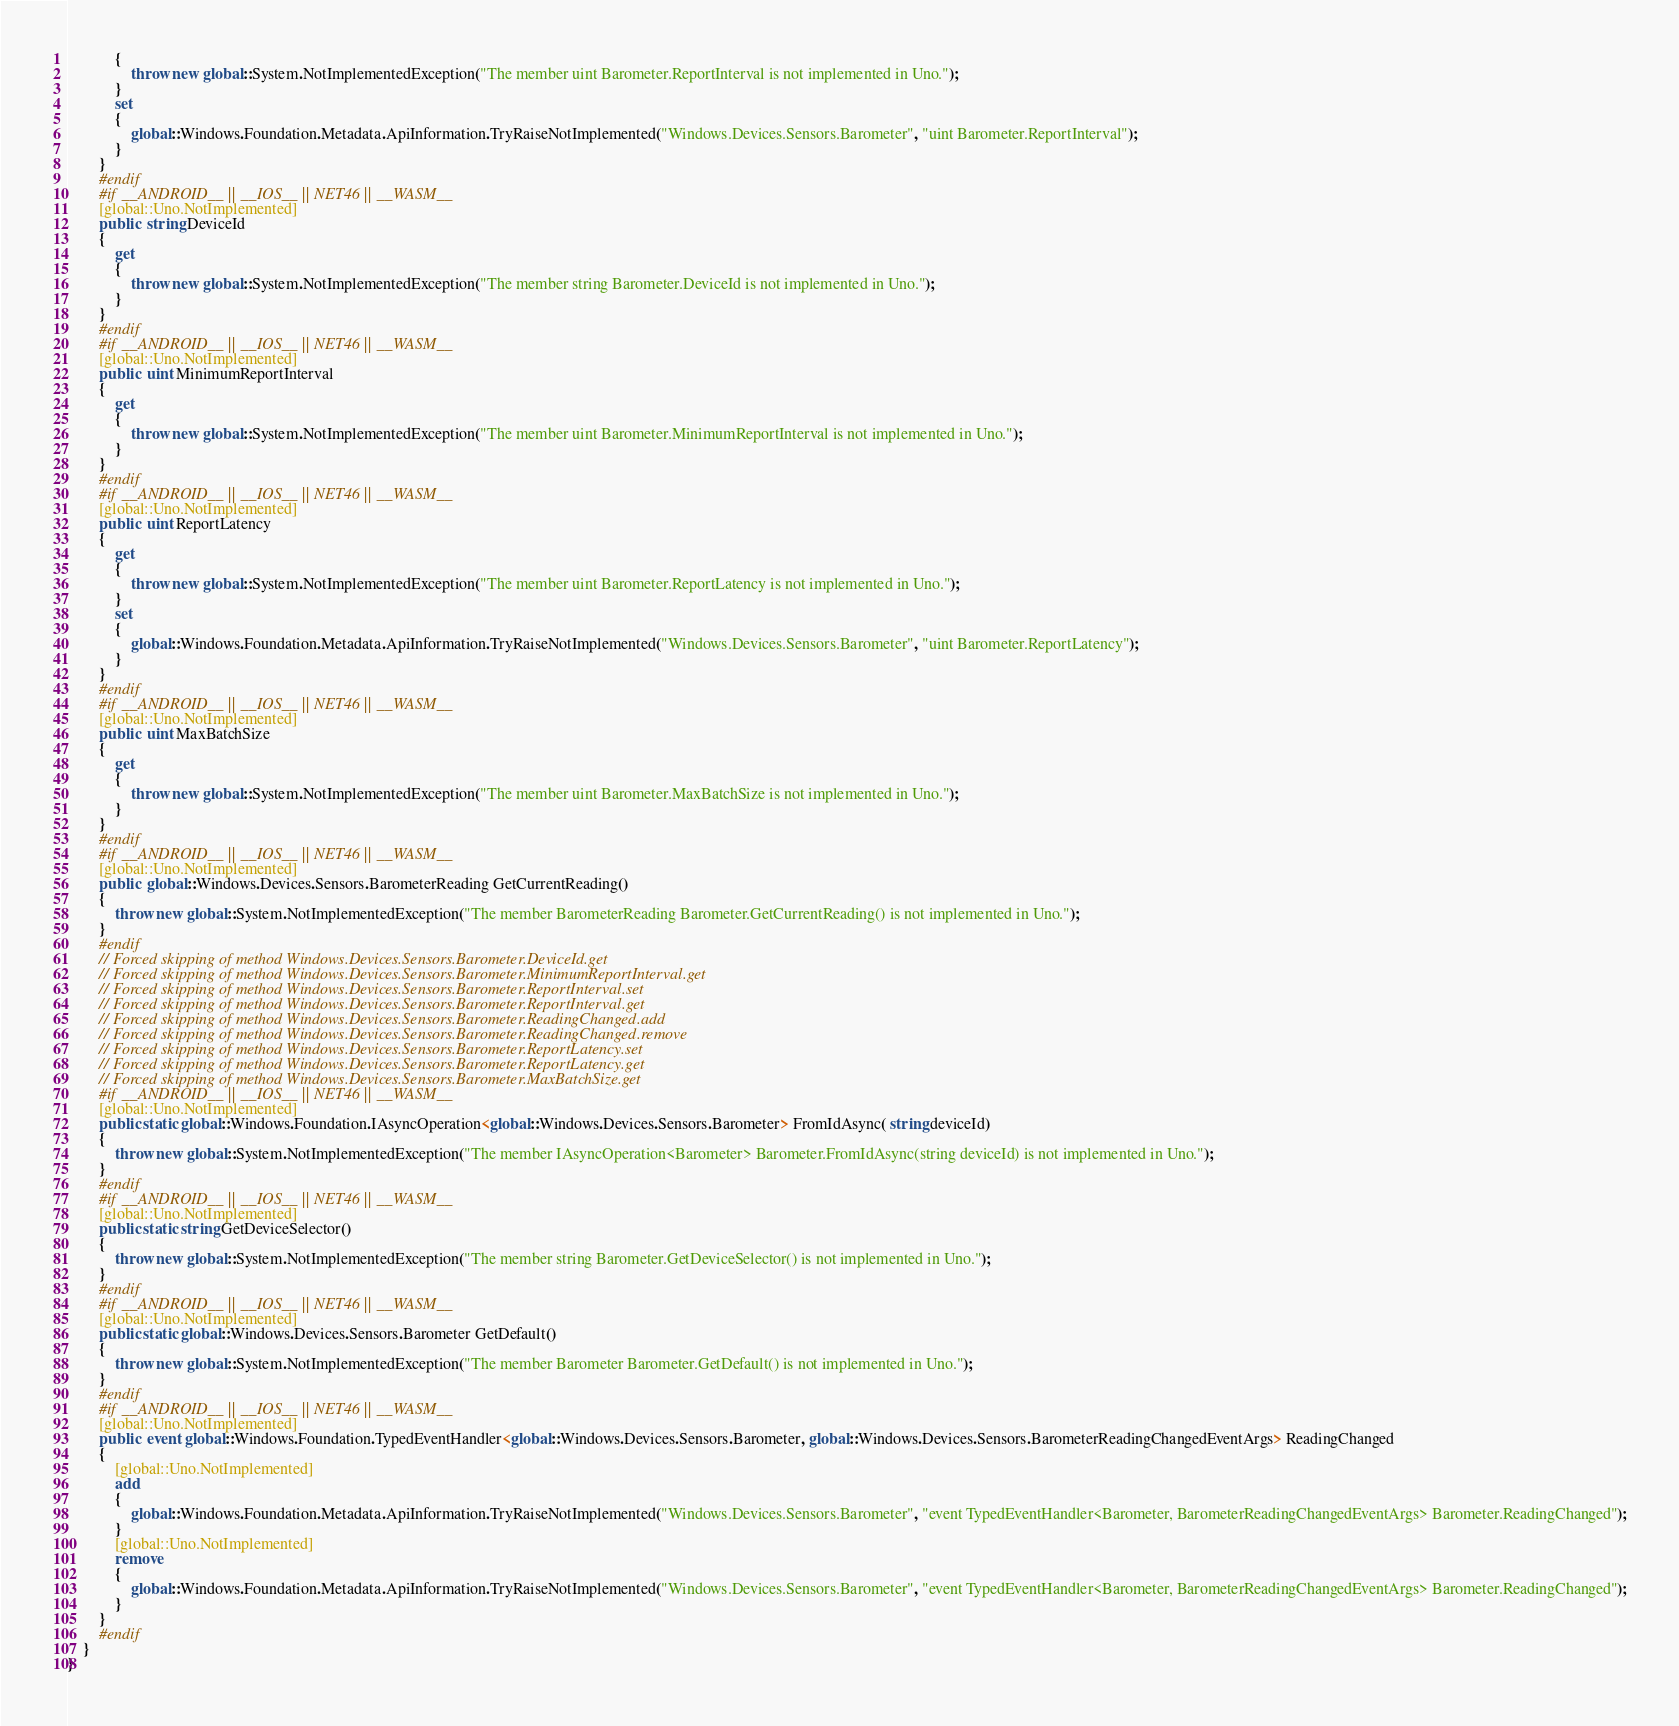<code> <loc_0><loc_0><loc_500><loc_500><_C#_>			{
				throw new global::System.NotImplementedException("The member uint Barometer.ReportInterval is not implemented in Uno.");
			}
			set
			{
				global::Windows.Foundation.Metadata.ApiInformation.TryRaiseNotImplemented("Windows.Devices.Sensors.Barometer", "uint Barometer.ReportInterval");
			}
		}
		#endif
		#if __ANDROID__ || __IOS__ || NET46 || __WASM__
		[global::Uno.NotImplemented]
		public  string DeviceId
		{
			get
			{
				throw new global::System.NotImplementedException("The member string Barometer.DeviceId is not implemented in Uno.");
			}
		}
		#endif
		#if __ANDROID__ || __IOS__ || NET46 || __WASM__
		[global::Uno.NotImplemented]
		public  uint MinimumReportInterval
		{
			get
			{
				throw new global::System.NotImplementedException("The member uint Barometer.MinimumReportInterval is not implemented in Uno.");
			}
		}
		#endif
		#if __ANDROID__ || __IOS__ || NET46 || __WASM__
		[global::Uno.NotImplemented]
		public  uint ReportLatency
		{
			get
			{
				throw new global::System.NotImplementedException("The member uint Barometer.ReportLatency is not implemented in Uno.");
			}
			set
			{
				global::Windows.Foundation.Metadata.ApiInformation.TryRaiseNotImplemented("Windows.Devices.Sensors.Barometer", "uint Barometer.ReportLatency");
			}
		}
		#endif
		#if __ANDROID__ || __IOS__ || NET46 || __WASM__
		[global::Uno.NotImplemented]
		public  uint MaxBatchSize
		{
			get
			{
				throw new global::System.NotImplementedException("The member uint Barometer.MaxBatchSize is not implemented in Uno.");
			}
		}
		#endif
		#if __ANDROID__ || __IOS__ || NET46 || __WASM__
		[global::Uno.NotImplemented]
		public  global::Windows.Devices.Sensors.BarometerReading GetCurrentReading()
		{
			throw new global::System.NotImplementedException("The member BarometerReading Barometer.GetCurrentReading() is not implemented in Uno.");
		}
		#endif
		// Forced skipping of method Windows.Devices.Sensors.Barometer.DeviceId.get
		// Forced skipping of method Windows.Devices.Sensors.Barometer.MinimumReportInterval.get
		// Forced skipping of method Windows.Devices.Sensors.Barometer.ReportInterval.set
		// Forced skipping of method Windows.Devices.Sensors.Barometer.ReportInterval.get
		// Forced skipping of method Windows.Devices.Sensors.Barometer.ReadingChanged.add
		// Forced skipping of method Windows.Devices.Sensors.Barometer.ReadingChanged.remove
		// Forced skipping of method Windows.Devices.Sensors.Barometer.ReportLatency.set
		// Forced skipping of method Windows.Devices.Sensors.Barometer.ReportLatency.get
		// Forced skipping of method Windows.Devices.Sensors.Barometer.MaxBatchSize.get
		#if __ANDROID__ || __IOS__ || NET46 || __WASM__
		[global::Uno.NotImplemented]
		public static global::Windows.Foundation.IAsyncOperation<global::Windows.Devices.Sensors.Barometer> FromIdAsync( string deviceId)
		{
			throw new global::System.NotImplementedException("The member IAsyncOperation<Barometer> Barometer.FromIdAsync(string deviceId) is not implemented in Uno.");
		}
		#endif
		#if __ANDROID__ || __IOS__ || NET46 || __WASM__
		[global::Uno.NotImplemented]
		public static string GetDeviceSelector()
		{
			throw new global::System.NotImplementedException("The member string Barometer.GetDeviceSelector() is not implemented in Uno.");
		}
		#endif
		#if __ANDROID__ || __IOS__ || NET46 || __WASM__
		[global::Uno.NotImplemented]
		public static global::Windows.Devices.Sensors.Barometer GetDefault()
		{
			throw new global::System.NotImplementedException("The member Barometer Barometer.GetDefault() is not implemented in Uno.");
		}
		#endif
		#if __ANDROID__ || __IOS__ || NET46 || __WASM__
		[global::Uno.NotImplemented]
		public  event global::Windows.Foundation.TypedEventHandler<global::Windows.Devices.Sensors.Barometer, global::Windows.Devices.Sensors.BarometerReadingChangedEventArgs> ReadingChanged
		{
			[global::Uno.NotImplemented]
			add
			{
				global::Windows.Foundation.Metadata.ApiInformation.TryRaiseNotImplemented("Windows.Devices.Sensors.Barometer", "event TypedEventHandler<Barometer, BarometerReadingChangedEventArgs> Barometer.ReadingChanged");
			}
			[global::Uno.NotImplemented]
			remove
			{
				global::Windows.Foundation.Metadata.ApiInformation.TryRaiseNotImplemented("Windows.Devices.Sensors.Barometer", "event TypedEventHandler<Barometer, BarometerReadingChangedEventArgs> Barometer.ReadingChanged");
			}
		}
		#endif
	}
}
</code> 